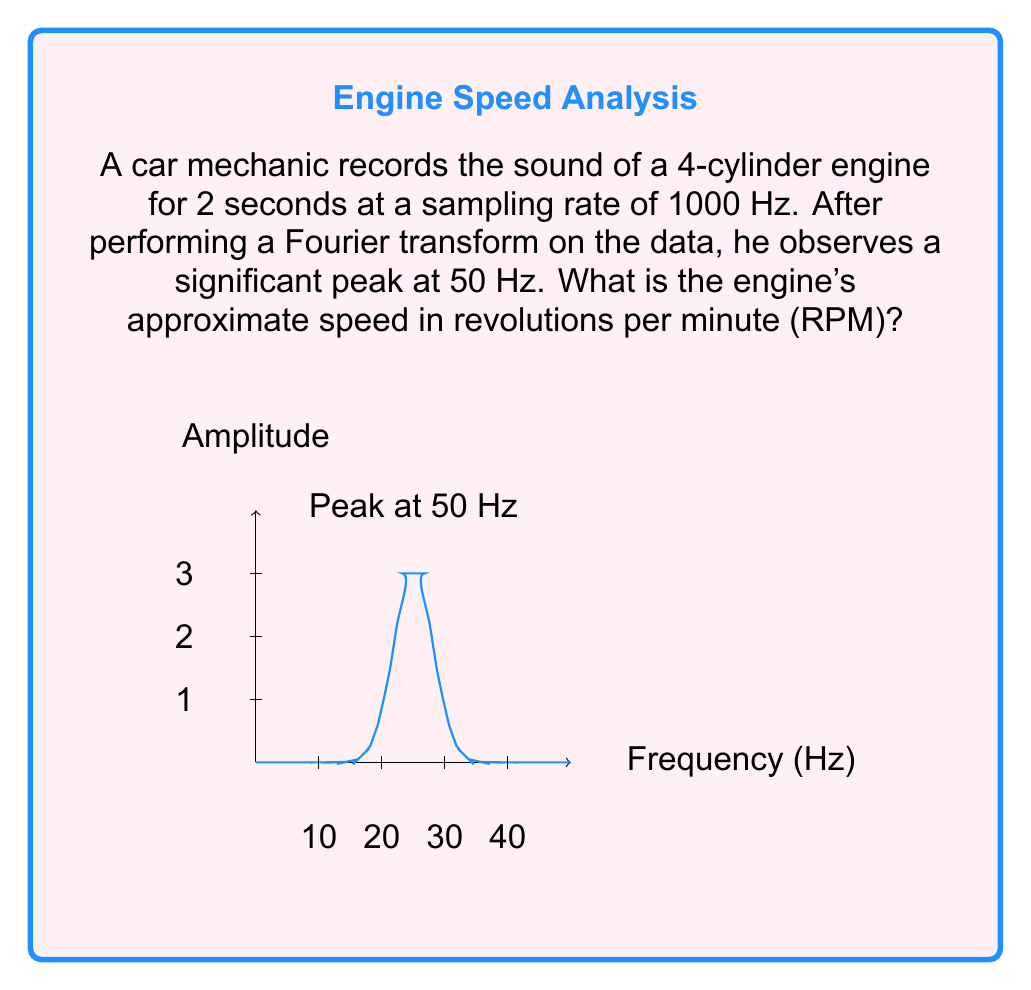What is the answer to this math problem? To solve this problem, let's follow these steps:

1) First, we need to understand what the 50 Hz peak represents. In a 4-cylinder engine, each cylinder fires once every two revolutions of the crankshaft. This means there are two firing events per revolution.

2) The frequency of 50 Hz means there are 50 events per second. Since each event corresponds to half a revolution, we can set up the following equation:

   $$50 \text{ events/second} \times \frac{1 \text{ revolution}}{2 \text{ events}} = 25 \text{ revolutions/second}$$

3) To convert revolutions per second to revolutions per minute (RPM), we multiply by 60 seconds/minute:

   $$25 \text{ revolutions/second} \times \frac{60 \text{ seconds}}{1 \text{ minute}} = 1500 \text{ RPM}$$

Therefore, the engine's approximate speed is 1500 RPM.
Answer: 1500 RPM 